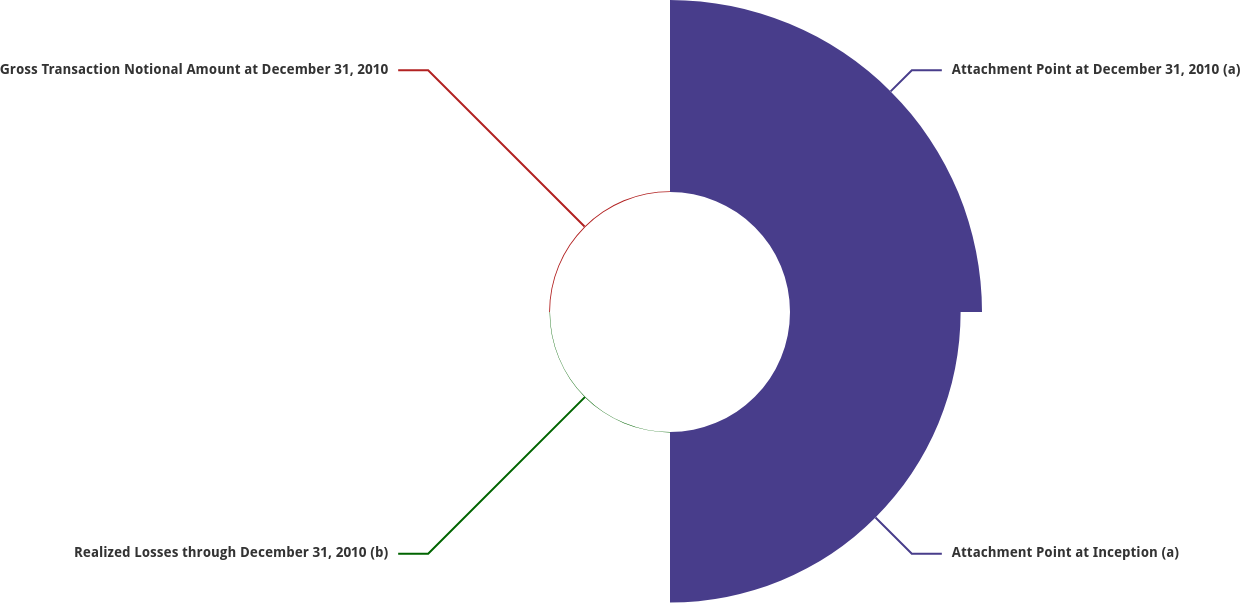Convert chart to OTSL. <chart><loc_0><loc_0><loc_500><loc_500><pie_chart><fcel>Attachment Point at December 31, 2010 (a)<fcel>Attachment Point at Inception (a)<fcel>Realized Losses through December 31, 2010 (b)<fcel>Gross Transaction Notional Amount at December 31, 2010<nl><fcel>52.77%<fcel>46.89%<fcel>0.11%<fcel>0.24%<nl></chart> 